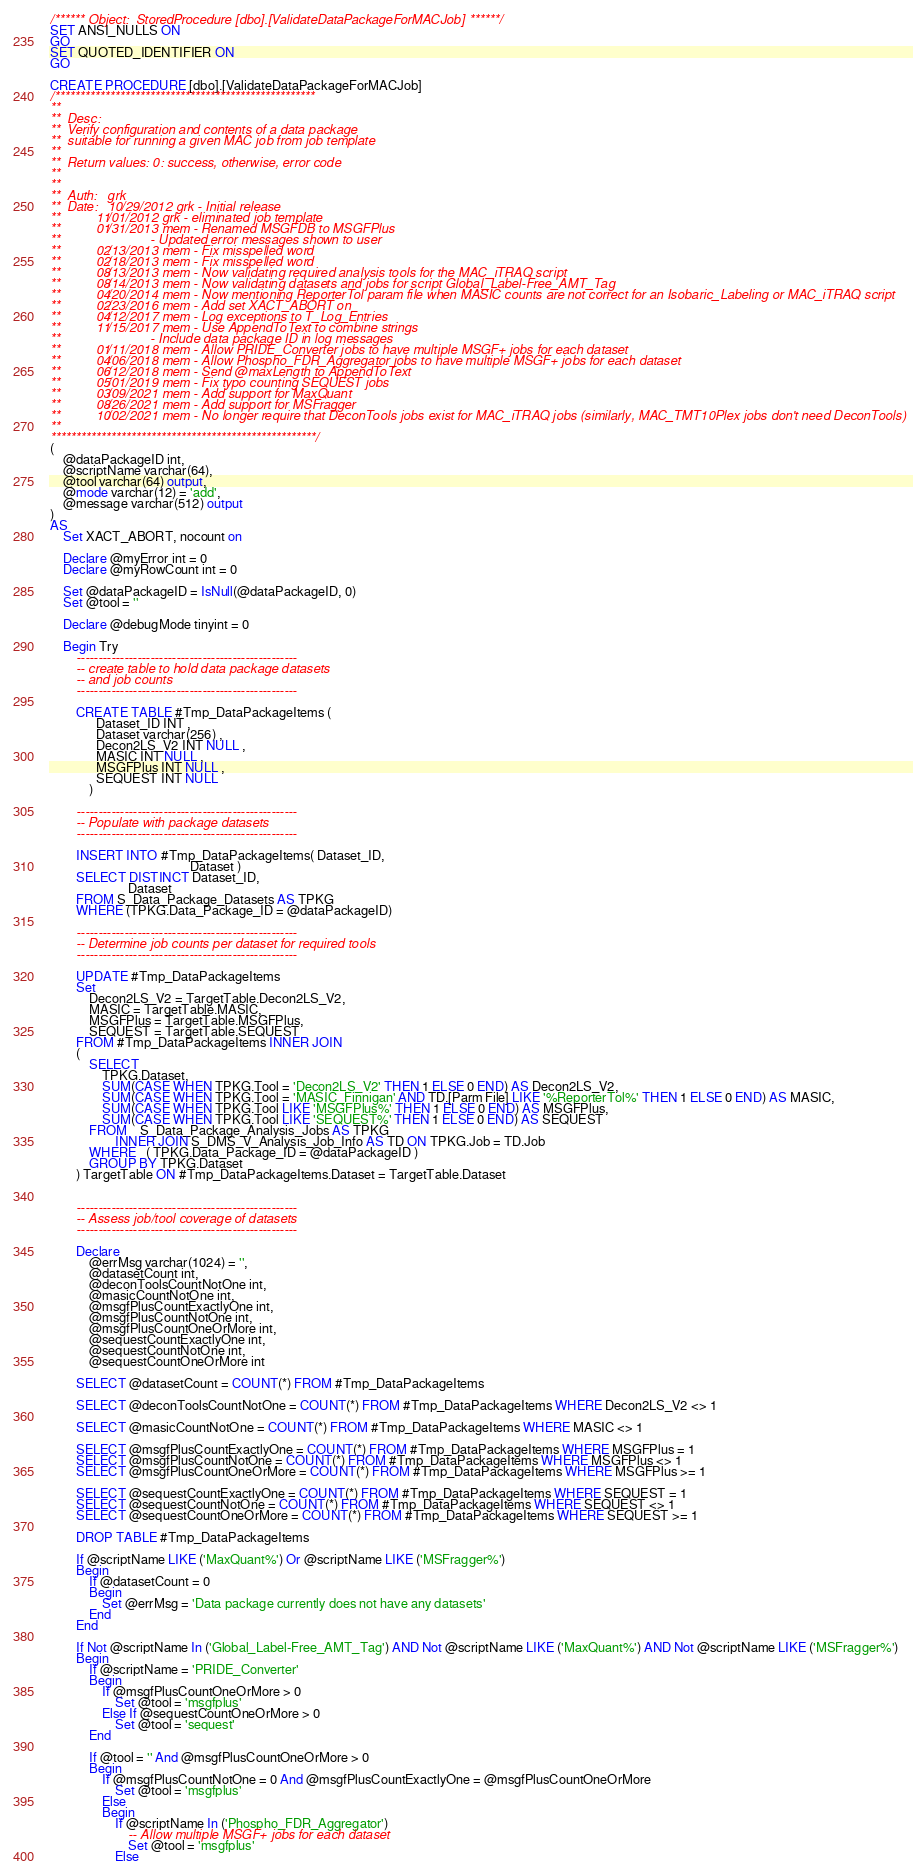<code> <loc_0><loc_0><loc_500><loc_500><_SQL_>/****** Object:  StoredProcedure [dbo].[ValidateDataPackageForMACJob] ******/
SET ANSI_NULLS ON
GO
SET QUOTED_IDENTIFIER ON
GO

CREATE PROCEDURE [dbo].[ValidateDataPackageForMACJob]
/****************************************************
**
**  Desc: 
**  Verify configuration and contents of a data package
**  suitable for running a given MAC job from job template 
**    
**  Return values: 0: success, otherwise, error code
**
**
**  Auth:   grk
**  Date:   10/29/2012 grk - Initial release
**          11/01/2012 grk - eliminated job template
**          01/31/2013 mem - Renamed MSGFDB to MSGFPlus
**                         - Updated error messages shown to user
**          02/13/2013 mem - Fix misspelled word
**          02/18/2013 mem - Fix misspelled word
**          08/13/2013 mem - Now validating required analysis tools for the MAC_iTRAQ script
**          08/14/2013 mem - Now validating datasets and jobs for script Global_Label-Free_AMT_Tag
**          04/20/2014 mem - Now mentioning ReporterTol param file when MASIC counts are not correct for an Isobaric_Labeling or MAC_iTRAQ script
**          02/23/2016 mem - Add set XACT_ABORT on
**          04/12/2017 mem - Log exceptions to T_Log_Entries
**          11/15/2017 mem - Use AppendToText to combine strings
**                         - Include data package ID in log messages
**          01/11/2018 mem - Allow PRIDE_Converter jobs to have multiple MSGF+ jobs for each dataset
**          04/06/2018 mem - Allow Phospho_FDR_Aggregator jobs to have multiple MSGF+ jobs for each dataset
**          06/12/2018 mem - Send @maxLength to AppendToText
**          05/01/2019 mem - Fix typo counting SEQUEST jobs
**          03/09/2021 mem - Add support for MaxQuant
**          08/26/2021 mem - Add support for MSFragger
**          10/02/2021 mem - No longer require that DeconTools jobs exist for MAC_iTRAQ jobs (similarly, MAC_TMT10Plex jobs don't need DeconTools)
**
*****************************************************/
(
    @dataPackageID int,
    @scriptName varchar(64),    
    @tool varchar(64) output,
    @mode varchar(12) = 'add', 
    @message varchar(512) output
)
AS
    Set XACT_ABORT, nocount on
    
    Declare @myError int = 0
    Declare @myRowCount int = 0

    Set @dataPackageID = IsNull(@dataPackageID, 0)
    Set @tool = ''

    Declare @debugMode tinyint = 0
    
    Begin Try                
        ---------------------------------------------------
        -- create table to hold data package datasets
        -- and job counts
        ---------------------------------------------------

        CREATE TABLE #Tmp_DataPackageItems (
              Dataset_ID INT ,
              Dataset varchar(256) ,
              Decon2LS_V2 INT NULL ,
              MASIC INT NULL ,
              MSGFPlus INT NULL ,
              SEQUEST INT NULL 
            )

        ---------------------------------------------------
        -- Populate with package datasets
        ---------------------------------------------------

        INSERT INTO #Tmp_DataPackageItems( Dataset_ID,
                                           Dataset )
        SELECT DISTINCT Dataset_ID,
                        Dataset
        FROM S_Data_Package_Datasets AS TPKG
        WHERE (TPKG.Data_Package_ID = @dataPackageID)

        ---------------------------------------------------
        -- Determine job counts per dataset for required tools
        ---------------------------------------------------

        UPDATE #Tmp_DataPackageItems
        Set 
            Decon2LS_V2 = TargetTable.Decon2LS_V2,
            MASIC = TargetTable.MASIC,
            MSGFPlus = TargetTable.MSGFPlus,
            SEQUEST = TargetTable.SEQUEST
        FROM #Tmp_DataPackageItems INNER JOIN 
        (
            SELECT  
                TPKG.Dataset,
                SUM(CASE WHEN TPKG.Tool = 'Decon2LS_V2' THEN 1 ELSE 0 END) AS Decon2LS_V2,
                SUM(CASE WHEN TPKG.Tool = 'MASIC_Finnigan' AND TD.[Parm File] LIKE '%ReporterTol%' THEN 1 ELSE 0 END) AS MASIC,
                SUM(CASE WHEN TPKG.Tool LIKE 'MSGFPlus%' THEN 1 ELSE 0 END) AS MSGFPlus,
                SUM(CASE WHEN TPKG.Tool LIKE 'SEQUEST%' THEN 1 ELSE 0 END) AS SEQUEST
            FROM    S_Data_Package_Analysis_Jobs AS TPKG
                    INNER JOIN S_DMS_V_Analysis_Job_Info AS TD ON TPKG.Job = TD.Job
            WHERE   ( TPKG.Data_Package_ID = @dataPackageID )
            GROUP BY TPKG.Dataset
        ) TargetTable ON #Tmp_DataPackageItems.Dataset = TargetTable.Dataset

        
        ---------------------------------------------------
        -- Assess job/tool coverage of datasets
        ---------------------------------------------------

        Declare 
            @errMsg varchar(1024) = '',
            @datasetCount int,
            @deconToolsCountNotOne int,
            @masicCountNotOne int,
            @msgfPlusCountExactlyOne int,
            @msgfPlusCountNotOne int,
            @msgfPlusCountOneOrMore int,
            @sequestCountExactlyOne int,
            @sequestCountNotOne int,
            @sequestCountOneOrMore int

        SELECT @datasetCount = COUNT(*) FROM #Tmp_DataPackageItems

        SELECT @deconToolsCountNotOne = COUNT(*) FROM #Tmp_DataPackageItems WHERE Decon2LS_V2 <> 1
        
        SELECT @masicCountNotOne = COUNT(*) FROM #Tmp_DataPackageItems WHERE MASIC <> 1
        
        SELECT @msgfPlusCountExactlyOne = COUNT(*) FROM #Tmp_DataPackageItems WHERE MSGFPlus = 1
        SELECT @msgfPlusCountNotOne = COUNT(*) FROM #Tmp_DataPackageItems WHERE MSGFPlus <> 1
        SELECT @msgfPlusCountOneOrMore = COUNT(*) FROM #Tmp_DataPackageItems WHERE MSGFPlus >= 1
        
        SELECT @sequestCountExactlyOne = COUNT(*) FROM #Tmp_DataPackageItems WHERE SEQUEST = 1
        SELECT @sequestCountNotOne = COUNT(*) FROM #Tmp_DataPackageItems WHERE SEQUEST <> 1
        SELECT @sequestCountOneOrMore = COUNT(*) FROM #Tmp_DataPackageItems WHERE SEQUEST >= 1

        DROP TABLE #Tmp_DataPackageItems

        If @scriptName LIKE ('MaxQuant%') Or @scriptName LIKE ('MSFragger%')
        Begin
            If @datasetCount = 0
            Begin
                Set @errMsg = 'Data package currently does not have any datasets'
            End
        End

        If Not @scriptName In ('Global_Label-Free_AMT_Tag') AND Not @scriptName LIKE ('MaxQuant%') AND Not @scriptName LIKE ('MSFragger%')
        Begin
            If @scriptName = 'PRIDE_Converter'
            Begin
                If @msgfPlusCountOneOrMore > 0
                    Set @tool = 'msgfplus'
                Else If @sequestCountOneOrMore > 0
                    Set @tool = 'sequest'
            End
   
            If @tool = '' And @msgfPlusCountOneOrMore > 0
            Begin
                If @msgfPlusCountNotOne = 0 And @msgfPlusCountExactlyOne = @msgfPlusCountOneOrMore
                    Set @tool = 'msgfplus'
                Else
                Begin
                    If @scriptName In ('Phospho_FDR_Aggregator')
                        -- Allow multiple MSGF+ jobs for each dataset
                        Set @tool = 'msgfplus'
                    Else</code> 